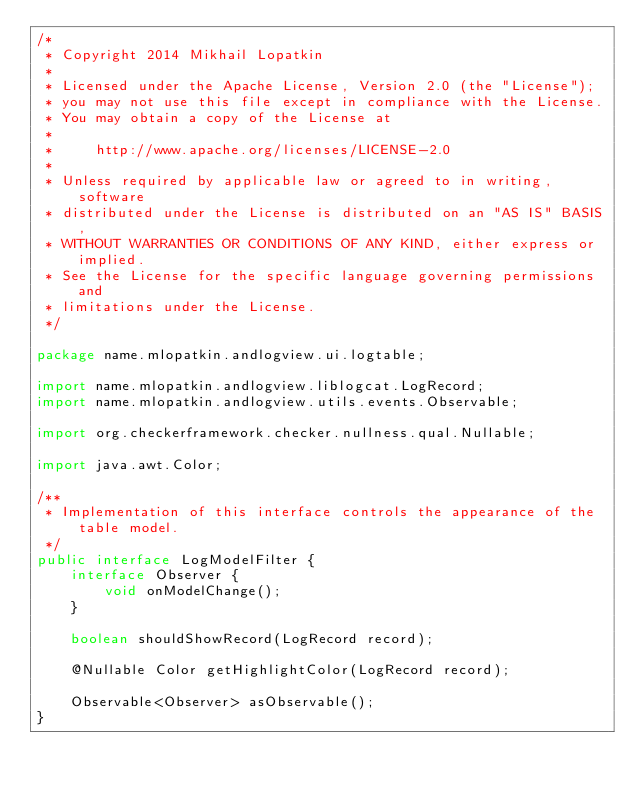Convert code to text. <code><loc_0><loc_0><loc_500><loc_500><_Java_>/*
 * Copyright 2014 Mikhail Lopatkin
 *
 * Licensed under the Apache License, Version 2.0 (the "License");
 * you may not use this file except in compliance with the License.
 * You may obtain a copy of the License at
 *
 *     http://www.apache.org/licenses/LICENSE-2.0
 *
 * Unless required by applicable law or agreed to in writing, software
 * distributed under the License is distributed on an "AS IS" BASIS,
 * WITHOUT WARRANTIES OR CONDITIONS OF ANY KIND, either express or implied.
 * See the License for the specific language governing permissions and
 * limitations under the License.
 */

package name.mlopatkin.andlogview.ui.logtable;

import name.mlopatkin.andlogview.liblogcat.LogRecord;
import name.mlopatkin.andlogview.utils.events.Observable;

import org.checkerframework.checker.nullness.qual.Nullable;

import java.awt.Color;

/**
 * Implementation of this interface controls the appearance of the table model.
 */
public interface LogModelFilter {
    interface Observer {
        void onModelChange();
    }

    boolean shouldShowRecord(LogRecord record);

    @Nullable Color getHighlightColor(LogRecord record);

    Observable<Observer> asObservable();
}
</code> 